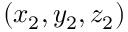<formula> <loc_0><loc_0><loc_500><loc_500>( x _ { 2 } , y _ { 2 } , z _ { 2 } )</formula> 